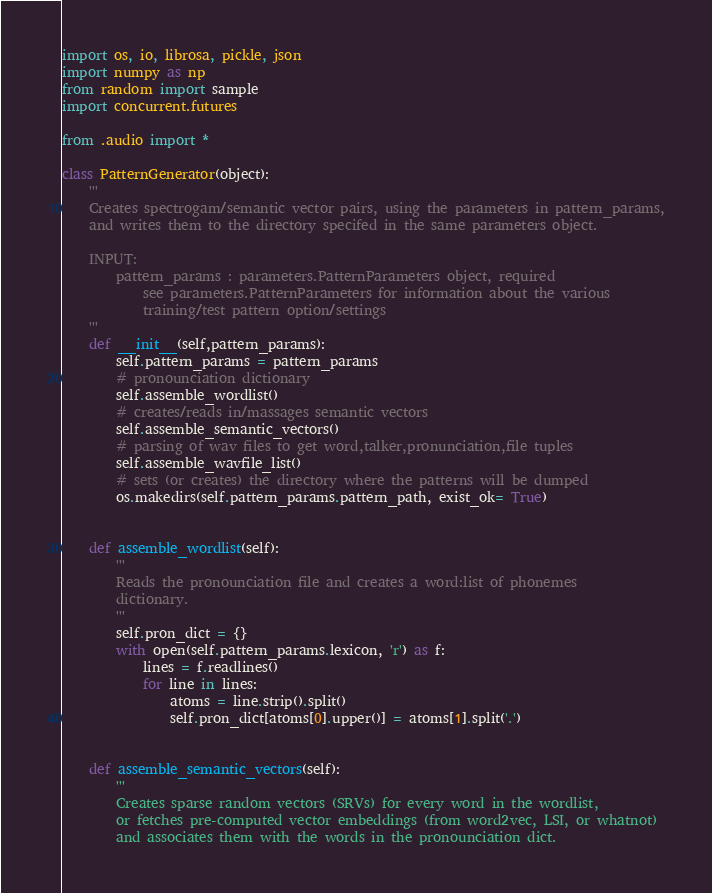Convert code to text. <code><loc_0><loc_0><loc_500><loc_500><_Python_>import os, io, librosa, pickle, json
import numpy as np
from random import sample
import concurrent.futures

from .audio import *

class PatternGenerator(object):
    '''
    Creates spectrogam/semantic vector pairs, using the parameters in pattern_params,
    and writes them to the directory specifed in the same parameters object.

    INPUT:
        pattern_params : parameters.PatternParameters object, required
            see parameters.PatternParameters for information about the various
            training/test pattern option/settings
    '''
    def __init__(self,pattern_params):
        self.pattern_params = pattern_params
        # pronounciation dictionary
        self.assemble_wordlist()
        # creates/reads in/massages semantic vectors
        self.assemble_semantic_vectors()
        # parsing of wav files to get word,talker,pronunciation,file tuples
        self.assemble_wavfile_list()
        # sets (or creates) the directory where the patterns will be dumped
        os.makedirs(self.pattern_params.pattern_path, exist_ok= True)


    def assemble_wordlist(self):
        '''
        Reads the pronounciation file and creates a word:list of phonemes
        dictionary.
        '''
        self.pron_dict = {}
        with open(self.pattern_params.lexicon, 'r') as f:
            lines = f.readlines()
            for line in lines:
                atoms = line.strip().split()
                self.pron_dict[atoms[0].upper()] = atoms[1].split('.')


    def assemble_semantic_vectors(self):
        '''
        Creates sparse random vectors (SRVs) for every word in the wordlist,
        or fetches pre-computed vector embeddings (from word2vec, LSI, or whatnot)
        and associates them with the words in the pronounciation dict.
</code> 